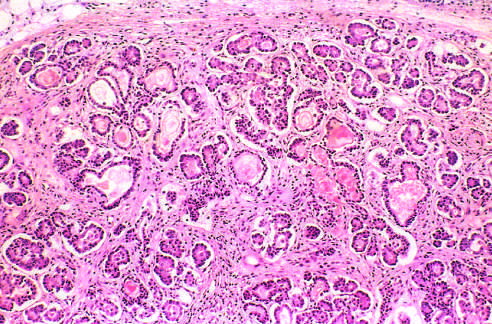re the ducts dilated and plugged with eosinophilic mucin?
Answer the question using a single word or phrase. Yes 